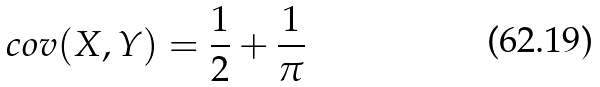Convert formula to latex. <formula><loc_0><loc_0><loc_500><loc_500>c o v ( X , Y ) = \frac { 1 } { 2 } + \frac { 1 } { \pi }</formula> 